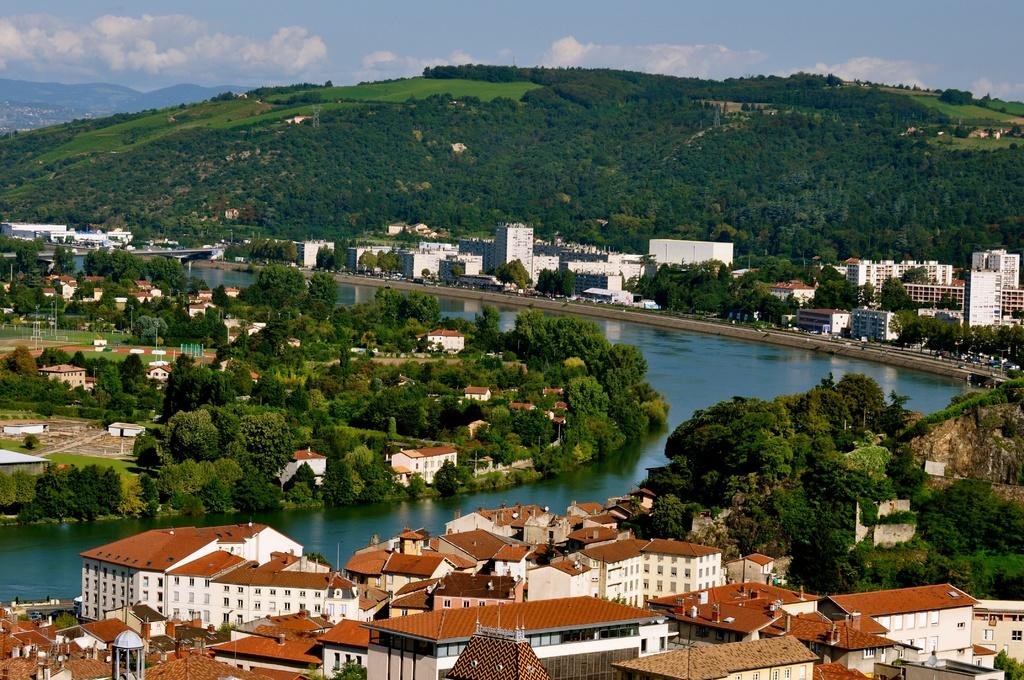What type of structures can be seen in the image? There are buildings in the image. What natural elements are present in the image? There are trees and hills visible in the image. What man-made objects can be seen in the image? There are poles and vehicles on the road in the image. What is the condition of the sky in the image? There are clouds in the sky at the top of the image. What natural feature is visible in the image? There is water visible in the image. What type of chain is being worn by the partner in the image? There is no partner present in the image, and therefore no chain can be observed. What type of cast is visible on the arm of the person in the image? There is no person with a cast present in the image. 